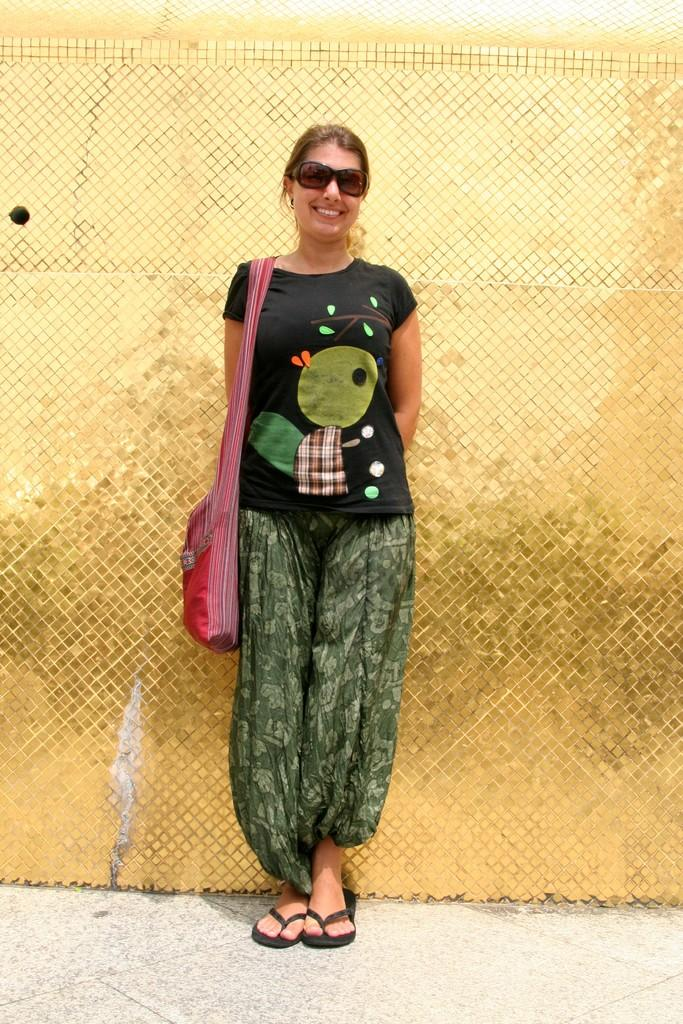What type of structure can be seen in the image? There is a fence in the image. What else is present in the image besides the fence? There are plants and a woman in the image. What is the woman wearing in the image? The woman is wearing a bag and a black color t-shirt. Can you see the moon in the image? No, the moon is not present in the image. Is the woman burning anything in the image? No, there is no indication of burning or fire in the image. 